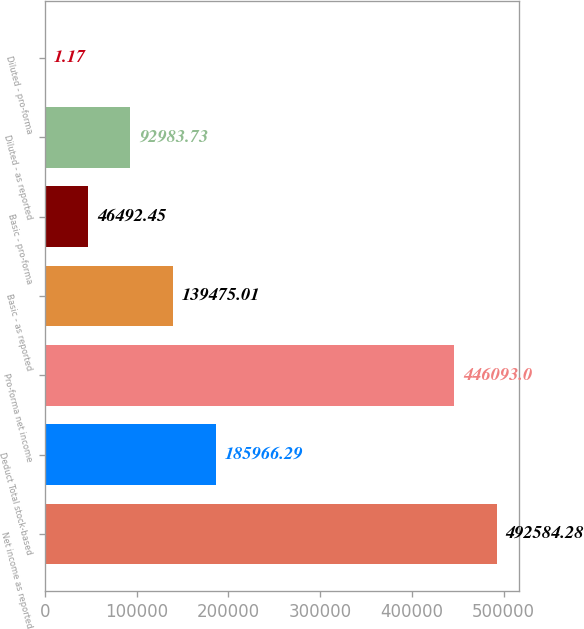Convert chart to OTSL. <chart><loc_0><loc_0><loc_500><loc_500><bar_chart><fcel>Net income as reported<fcel>Deduct Total stock-based<fcel>Pro-forma net income<fcel>Basic - as reported<fcel>Basic - pro-forma<fcel>Diluted - as reported<fcel>Diluted - pro-forma<nl><fcel>492584<fcel>185966<fcel>446093<fcel>139475<fcel>46492.4<fcel>92983.7<fcel>1.17<nl></chart> 